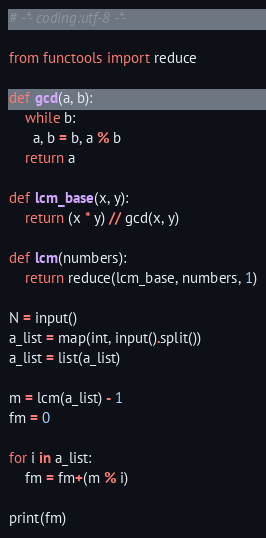Convert code to text. <code><loc_0><loc_0><loc_500><loc_500><_Python_># -*- coding:utf-8 -*-

from functools import reduce

def gcd(a, b):
    while b:
      a, b = b, a % b
    return a

def lcm_base(x, y):
    return (x * y) // gcd(x, y)

def lcm(numbers):
    return reduce(lcm_base, numbers, 1)

N = input()
a_list = map(int, input().split())
a_list = list(a_list)

m = lcm(a_list) - 1
fm = 0

for i in a_list:
    fm = fm+(m % i)

print(fm)</code> 